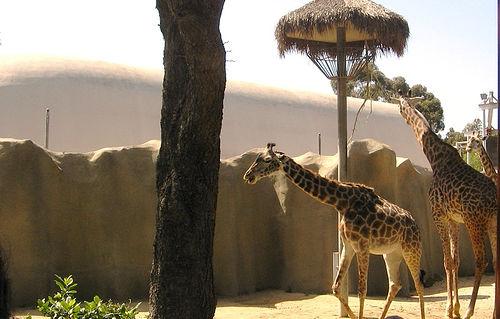How many giraffes are there?
Give a very brief answer. 3. Is the sun out and shining or is it night time?
Concise answer only. Sun out and shining. How many giraffe are walking by the wall?
Quick response, please. 3. 